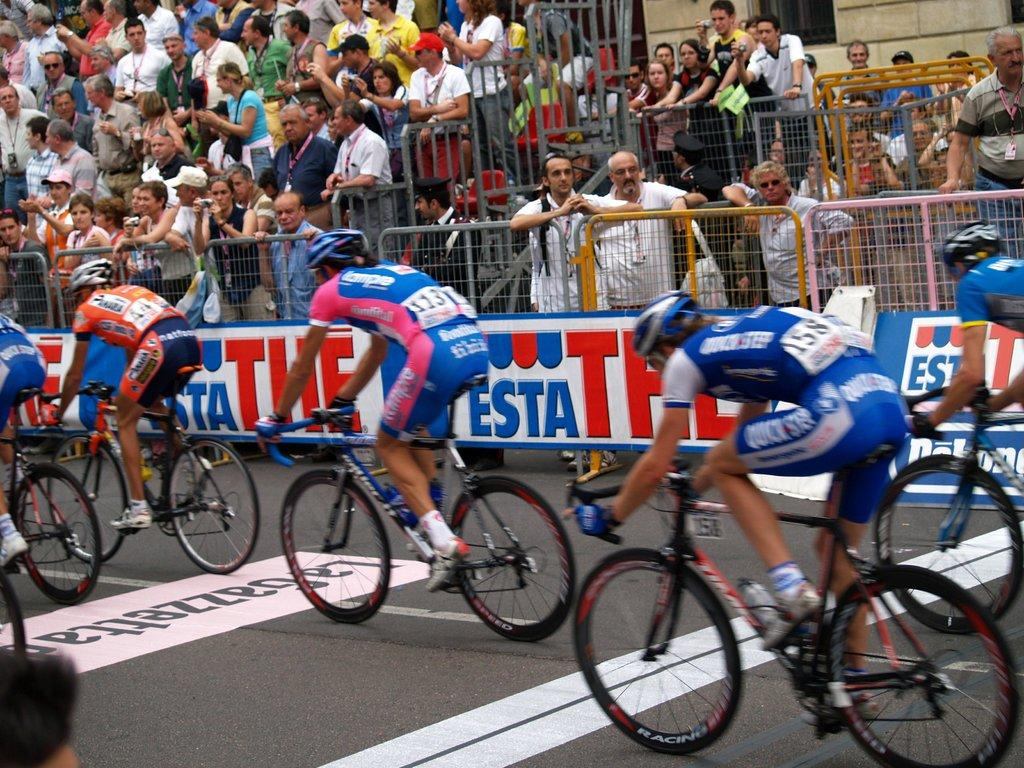<image>
Render a clear and concise summary of the photo. A bicycle race with a crowd in attendance behind a fence which bears a banner reading THE Esta. 